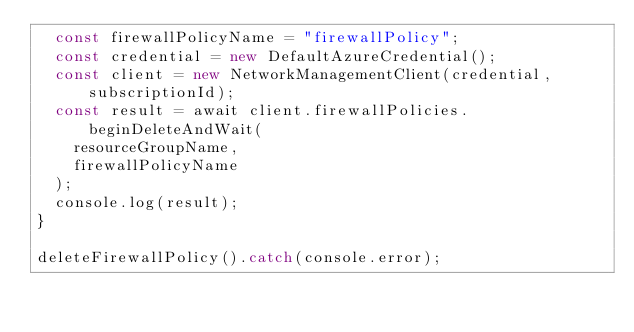Convert code to text. <code><loc_0><loc_0><loc_500><loc_500><_JavaScript_>  const firewallPolicyName = "firewallPolicy";
  const credential = new DefaultAzureCredential();
  const client = new NetworkManagementClient(credential, subscriptionId);
  const result = await client.firewallPolicies.beginDeleteAndWait(
    resourceGroupName,
    firewallPolicyName
  );
  console.log(result);
}

deleteFirewallPolicy().catch(console.error);
</code> 